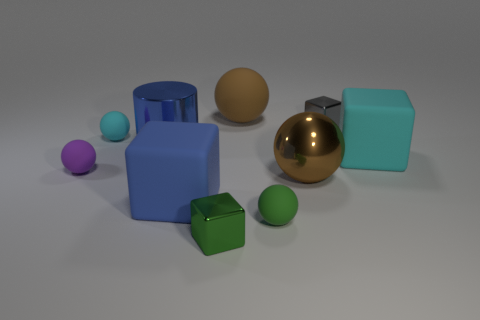How many tiny objects are cubes or cyan matte cylinders? After carefully examining the image, there are a total of two tiny objects that fit the description. One is a green cube, and the other is a cyan matte cylinder. 